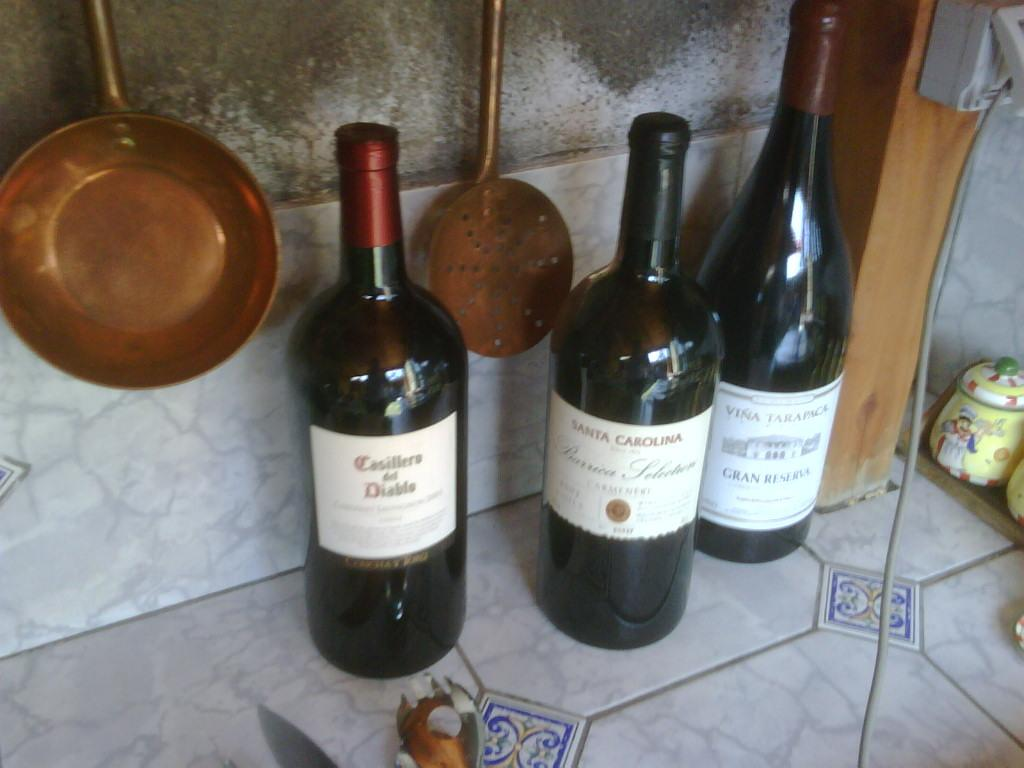<image>
Offer a succinct explanation of the picture presented. Three bottles of wine are on a counter, one of which is Casillero del Diablo. 